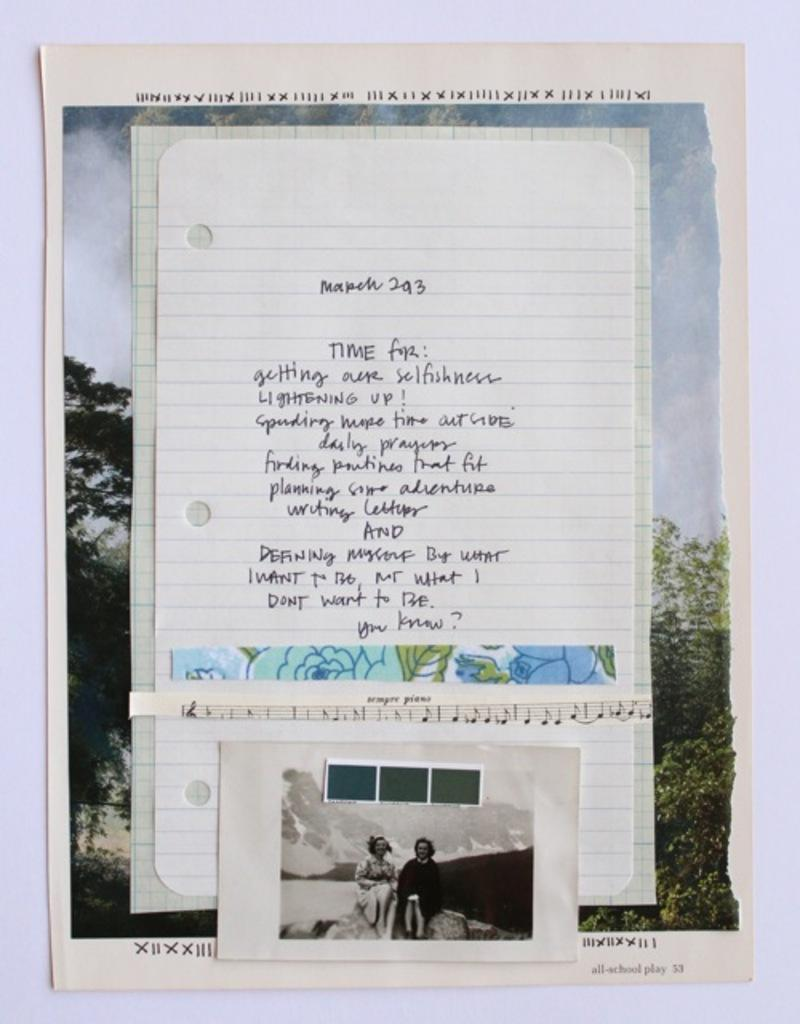<image>
Present a compact description of the photo's key features. A notebook page where somebody wrote what they want to do, including lightening up, saying daily prayers, and planning some adventures. 